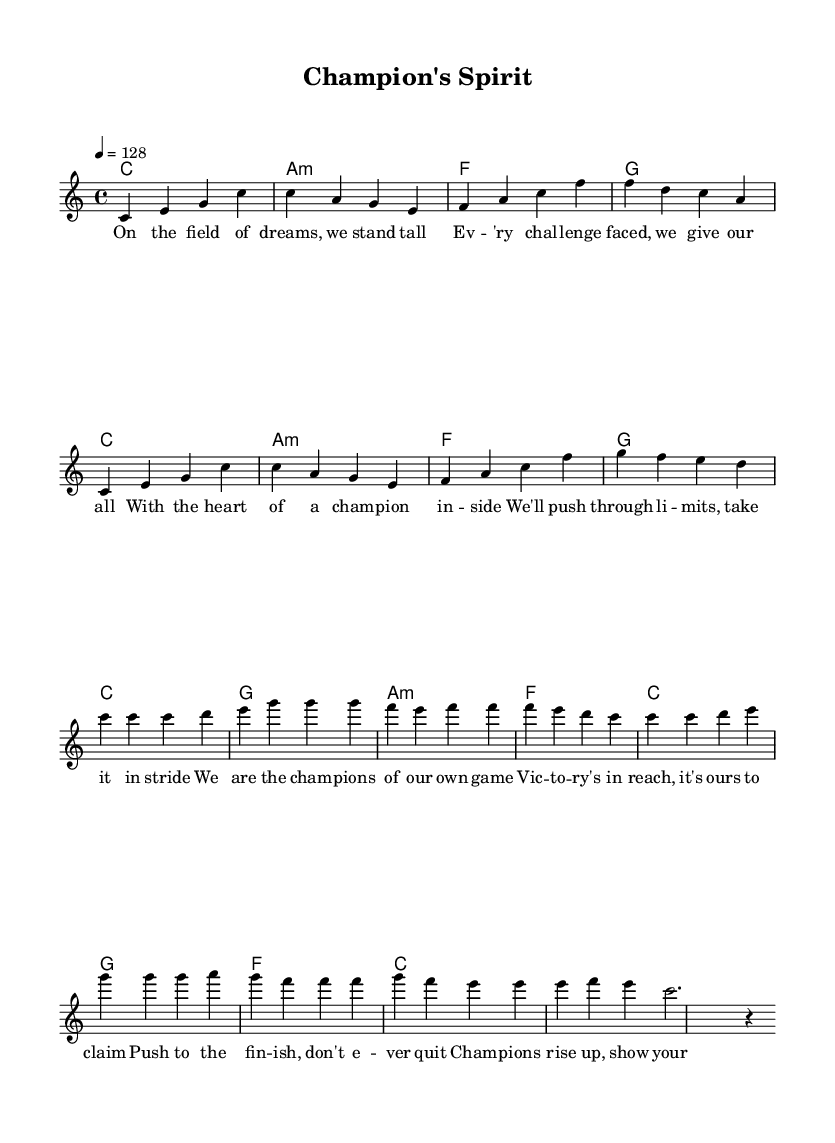What is the key signature of this music? The key signature is indicated at the beginning of the sheet music and shows no sharps or flats, which means it is in C major.
Answer: C major What is the time signature of this music? The time signature is also displayed at the beginning and shows a 4 over 4, indicating that there are four beats in a measure and the quarter note receives one beat.
Answer: 4/4 What is the tempo marking in this music? The tempo is specified as "4 = 128," which indicates that the quarter note should be played at a speed of 128 beats per minute.
Answer: 128 How many measures are in the chorus section? By counting the number of measures in the chorus portion of the melody, we see that there are eight measures.
Answer: 8 Which chord is played for the first measure of the verse? Looking at the chord symbols above the melody, the first chord for the verse is C major, represented as 'c'.
Answer: C What is the message conveyed in the chorus lyrics? Analyzing the lyrics, themes of empowerment, perseverance, and striving for victory are evident, highlighted by the phrases referring to being champions and showing grit.
Answer: Empowerment What is the overall theme of the song as indicated by the lyrics? The lyrics suggest a sporting and competitive theme, emphasizing resilience and the spirit of a champion fighting against challenges.
Answer: Competitive spirit 